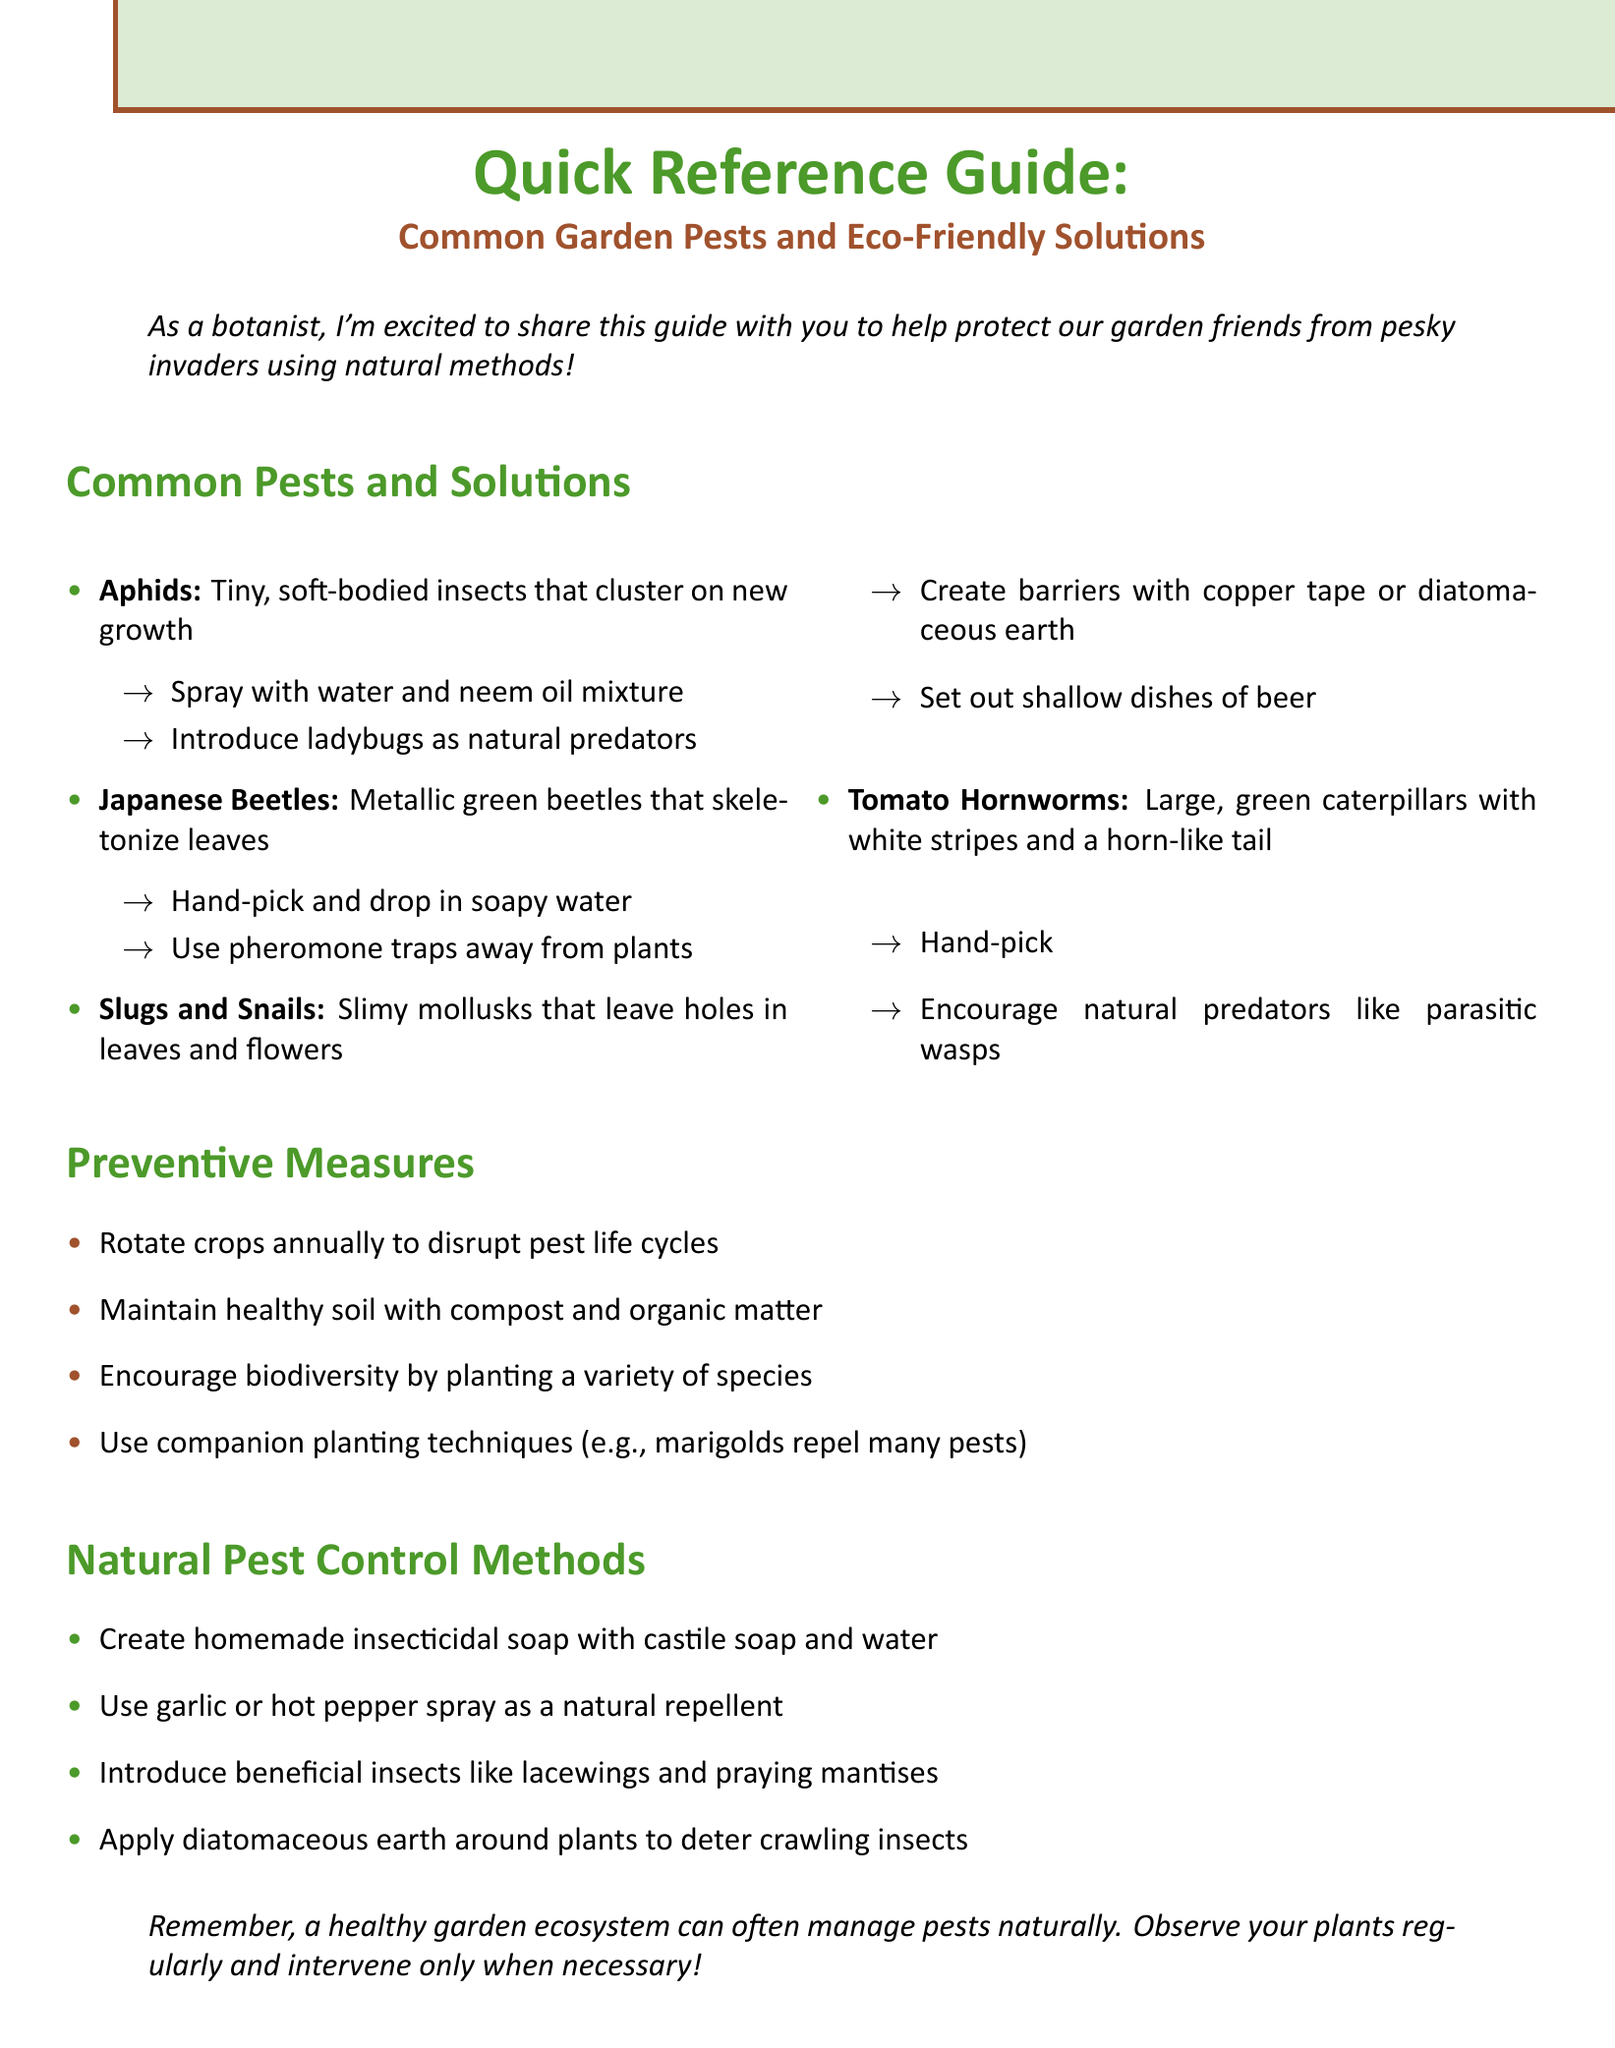What is the title of the guide? The title is prominently displayed at the beginning of the document as an introduction to its content.
Answer: Quick Reference Guide: Common Garden Pests and Eco-Friendly Solutions What are aphids? Aphids are specifically described in the section detailing common pests, identifying their characteristics and behaviors.
Answer: Tiny, soft-bodied insects that cluster on new growth What solution is suggested for Japanese beetles? The document lists solutions for pests, including effective methods for Japanese beetles and others.
Answer: Hand-pick and drop in soapy water, or use pheromone traps away from plants How can slugs and snails be deterred? The guide provides specific methods to combat slugs and snails, describing the recommended eco-friendly barriers.
Answer: Create barriers with copper tape or diatomaceous earth, or set out shallow dishes of beer What is one preventive measure mentioned? The preventive measures section outlines strategies for maintaining a healthy garden ecosystem, which are important for pest control.
Answer: Rotate crops annually to disrupt pest life cycles Which natural pest control method involves soap? The document provides several eco-friendly pest control methods, including specific formulas using common household items.
Answer: Create homemade insecticidal soap with castile soap and water Name a beneficial insect introduced in the guide. The guide includes various beneficial insects that can aid in pest control, highlighting their advantages.
Answer: Lacewings What is the overall message of the conclusion? The conclusion wraps up the guide with an encouraging note about maintaining a healthy garden ecosystem and pest management.
Answer: A healthy garden ecosystem can often manage pests naturally 